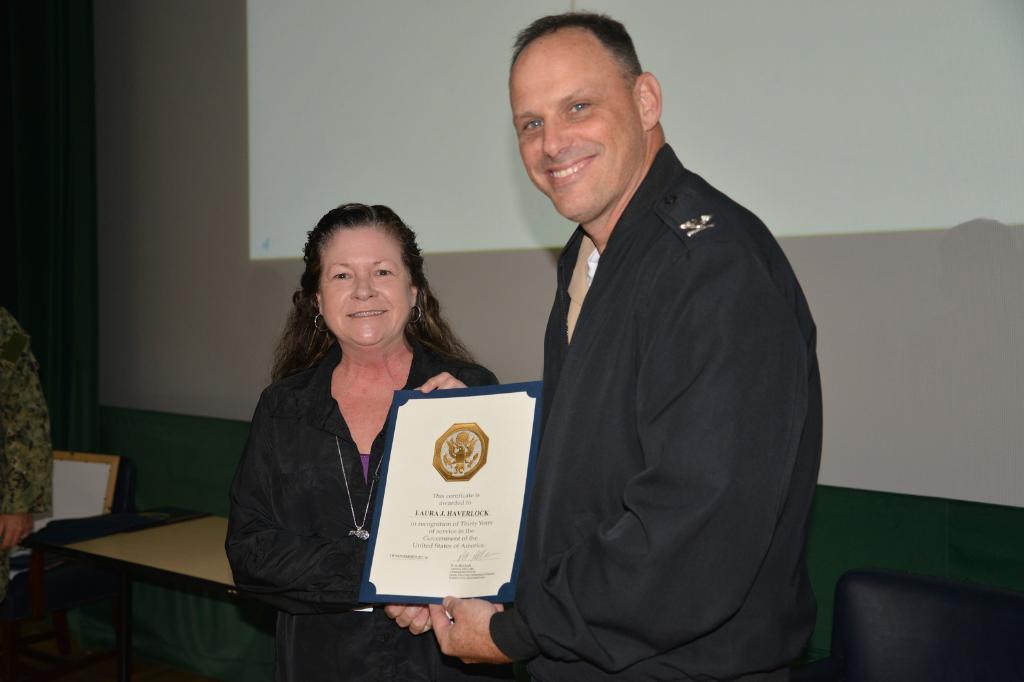Please provide a concise description of this image. In this image, In the middle there are two persons standing and holding a certificate which is in white color, In the background there is a table which is in yellow color, There is a wall which is in white color. 